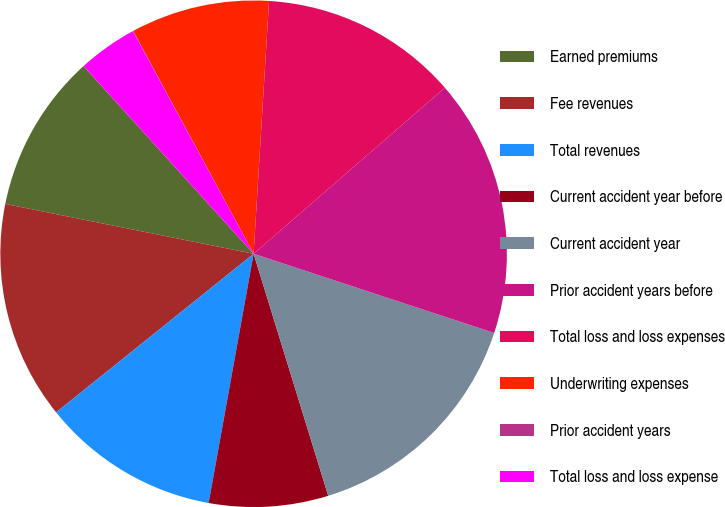Convert chart. <chart><loc_0><loc_0><loc_500><loc_500><pie_chart><fcel>Earned premiums<fcel>Fee revenues<fcel>Total revenues<fcel>Current accident year before<fcel>Current accident year<fcel>Prior accident years before<fcel>Total loss and loss expenses<fcel>Underwriting expenses<fcel>Prior accident years<fcel>Total loss and loss expense<nl><fcel>10.13%<fcel>13.92%<fcel>11.39%<fcel>7.6%<fcel>15.18%<fcel>16.44%<fcel>12.65%<fcel>8.86%<fcel>0.02%<fcel>3.81%<nl></chart> 